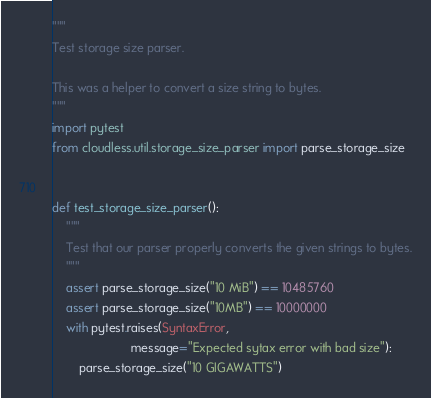<code> <loc_0><loc_0><loc_500><loc_500><_Python_>"""
Test storage size parser.

This was a helper to convert a size string to bytes.
"""
import pytest
from cloudless.util.storage_size_parser import parse_storage_size


def test_storage_size_parser():
    """
    Test that our parser properly converts the given strings to bytes.
    """
    assert parse_storage_size("10 MiB") == 10485760
    assert parse_storage_size("10MB") == 10000000
    with pytest.raises(SyntaxError,
                       message="Expected sytax error with bad size"):
        parse_storage_size("10 GIGAWATTS")
</code> 